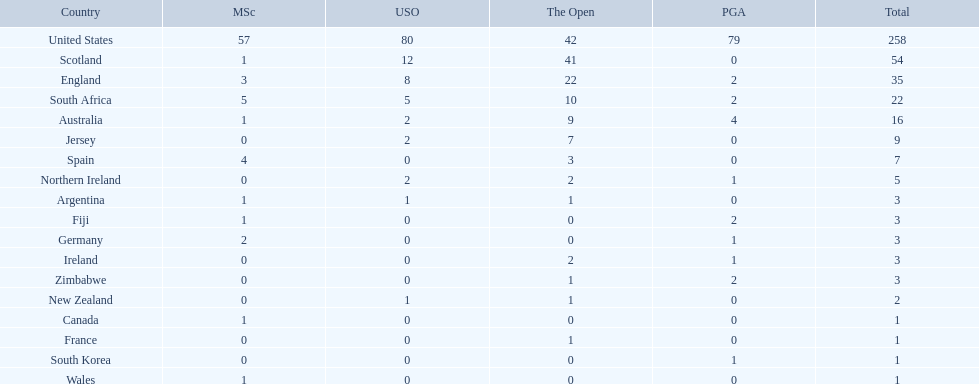What are all the countries? United States, Scotland, England, South Africa, Australia, Jersey, Spain, Northern Ireland, Argentina, Fiji, Germany, Ireland, Zimbabwe, New Zealand, Canada, France, South Korea, Wales. Which ones are located in africa? South Africa, Zimbabwe. Of those, which has the least champion golfers? Zimbabwe. 